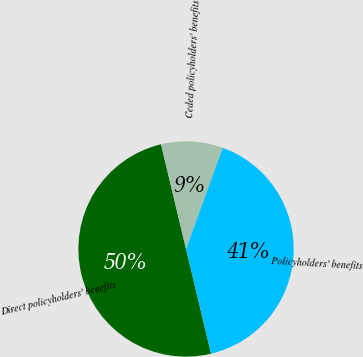Convert chart. <chart><loc_0><loc_0><loc_500><loc_500><pie_chart><fcel>Direct policyholders' benefits<fcel>Ceded policyholders' benefits<fcel>Policyholders' benefits<nl><fcel>50.0%<fcel>9.27%<fcel>40.73%<nl></chart> 